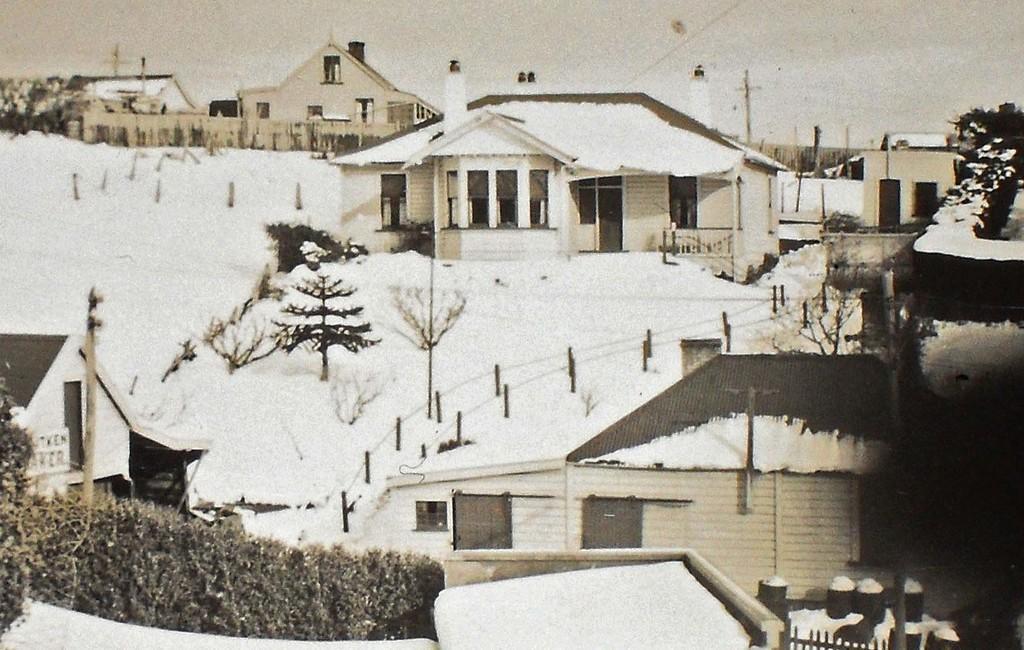In one or two sentences, can you explain what this image depicts? This is a black and white image, in this image the land is covered with snow and there are houses, trees and poles. 